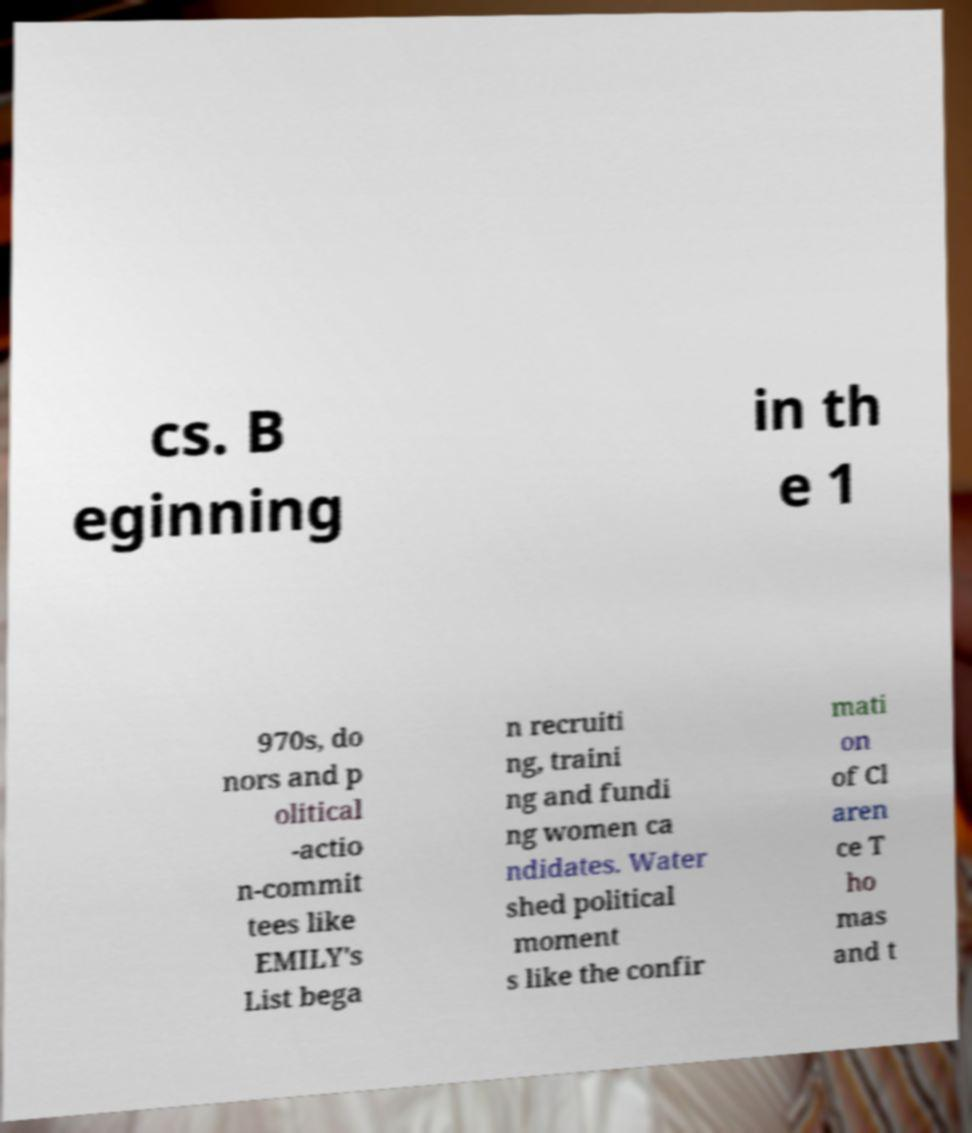Please identify and transcribe the text found in this image. cs. B eginning in th e 1 970s, do nors and p olitical -actio n-commit tees like EMILY's List bega n recruiti ng, traini ng and fundi ng women ca ndidates. Water shed political moment s like the confir mati on of Cl aren ce T ho mas and t 